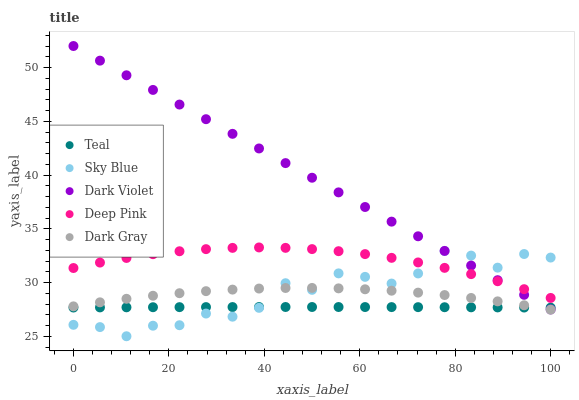Does Teal have the minimum area under the curve?
Answer yes or no. Yes. Does Dark Violet have the maximum area under the curve?
Answer yes or no. Yes. Does Sky Blue have the minimum area under the curve?
Answer yes or no. No. Does Sky Blue have the maximum area under the curve?
Answer yes or no. No. Is Dark Violet the smoothest?
Answer yes or no. Yes. Is Sky Blue the roughest?
Answer yes or no. Yes. Is Deep Pink the smoothest?
Answer yes or no. No. Is Deep Pink the roughest?
Answer yes or no. No. Does Sky Blue have the lowest value?
Answer yes or no. Yes. Does Deep Pink have the lowest value?
Answer yes or no. No. Does Dark Violet have the highest value?
Answer yes or no. Yes. Does Sky Blue have the highest value?
Answer yes or no. No. Is Dark Gray less than Dark Violet?
Answer yes or no. Yes. Is Deep Pink greater than Dark Gray?
Answer yes or no. Yes. Does Dark Gray intersect Teal?
Answer yes or no. Yes. Is Dark Gray less than Teal?
Answer yes or no. No. Is Dark Gray greater than Teal?
Answer yes or no. No. Does Dark Gray intersect Dark Violet?
Answer yes or no. No. 